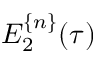<formula> <loc_0><loc_0><loc_500><loc_500>E _ { 2 } ^ { \{ n \} } ( \tau )</formula> 